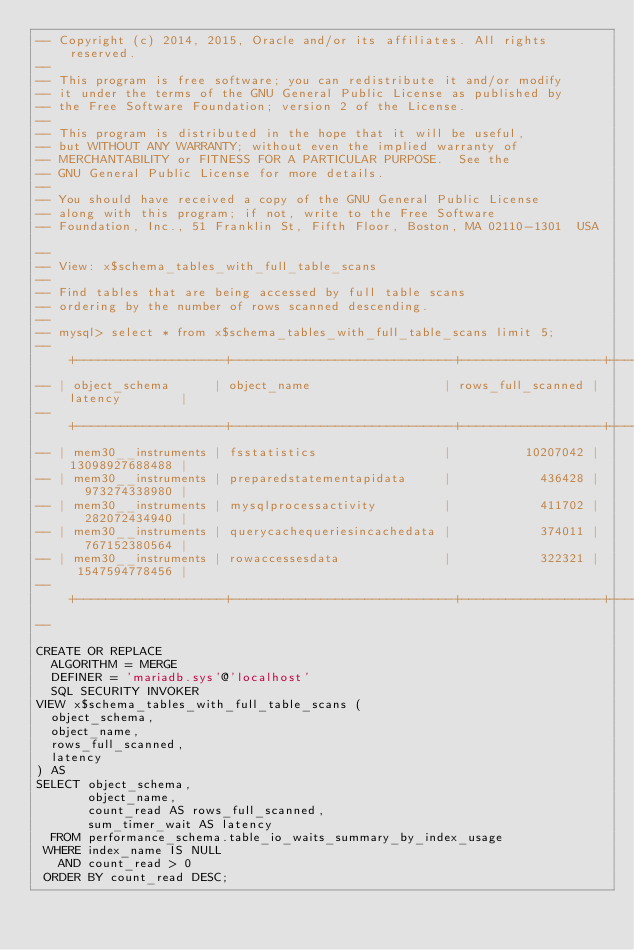<code> <loc_0><loc_0><loc_500><loc_500><_SQL_>-- Copyright (c) 2014, 2015, Oracle and/or its affiliates. All rights reserved.
--
-- This program is free software; you can redistribute it and/or modify
-- it under the terms of the GNU General Public License as published by
-- the Free Software Foundation; version 2 of the License.
--
-- This program is distributed in the hope that it will be useful,
-- but WITHOUT ANY WARRANTY; without even the implied warranty of
-- MERCHANTABILITY or FITNESS FOR A PARTICULAR PURPOSE.  See the
-- GNU General Public License for more details.
--
-- You should have received a copy of the GNU General Public License
-- along with this program; if not, write to the Free Software
-- Foundation, Inc., 51 Franklin St, Fifth Floor, Boston, MA 02110-1301  USA

--
-- View: x$schema_tables_with_full_table_scans
--
-- Find tables that are being accessed by full table scans
-- ordering by the number of rows scanned descending.
--
-- mysql> select * from x$schema_tables_with_full_table_scans limit 5;
-- +--------------------+------------------------------+-------------------+----------------+
-- | object_schema      | object_name                  | rows_full_scanned | latency        |
-- +--------------------+------------------------------+-------------------+----------------+
-- | mem30__instruments | fsstatistics                 |          10207042 | 13098927688488 |
-- | mem30__instruments | preparedstatementapidata     |            436428 |   973274338980 |
-- | mem30__instruments | mysqlprocessactivity         |            411702 |   282072434940 |
-- | mem30__instruments | querycachequeriesincachedata |            374011 |   767152380564 |
-- | mem30__instruments | rowaccessesdata              |            322321 |  1547594778456 |
-- +--------------------+------------------------------+-------------------+----------------+
--

CREATE OR REPLACE
  ALGORITHM = MERGE
  DEFINER = 'mariadb.sys'@'localhost'
  SQL SECURITY INVOKER 
VIEW x$schema_tables_with_full_table_scans (
  object_schema,
  object_name,
  rows_full_scanned,
  latency
) AS
SELECT object_schema, 
       object_name,
       count_read AS rows_full_scanned,
       sum_timer_wait AS latency
  FROM performance_schema.table_io_waits_summary_by_index_usage 
 WHERE index_name IS NULL
   AND count_read > 0
 ORDER BY count_read DESC;
</code> 